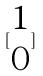<formula> <loc_0><loc_0><loc_500><loc_500>[ \begin{matrix} 1 \\ 0 \end{matrix} ]</formula> 